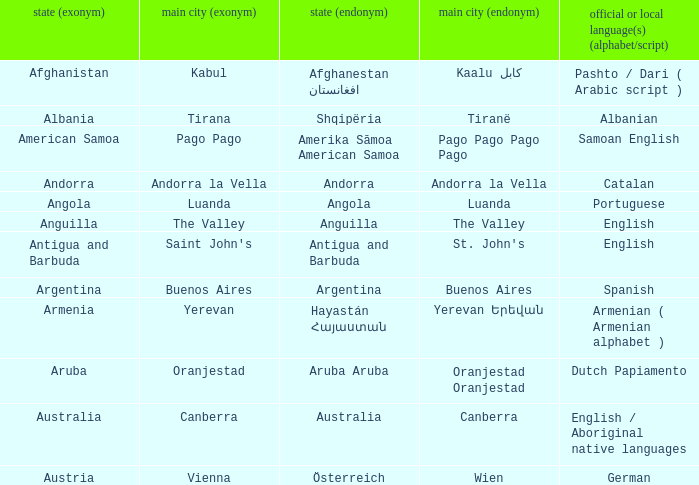What official or native languages are spoken in the country whose capital city is Canberra? English / Aboriginal native languages. 